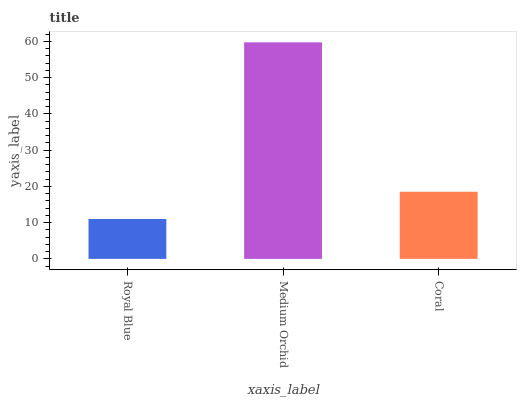Is Royal Blue the minimum?
Answer yes or no. Yes. Is Medium Orchid the maximum?
Answer yes or no. Yes. Is Coral the minimum?
Answer yes or no. No. Is Coral the maximum?
Answer yes or no. No. Is Medium Orchid greater than Coral?
Answer yes or no. Yes. Is Coral less than Medium Orchid?
Answer yes or no. Yes. Is Coral greater than Medium Orchid?
Answer yes or no. No. Is Medium Orchid less than Coral?
Answer yes or no. No. Is Coral the high median?
Answer yes or no. Yes. Is Coral the low median?
Answer yes or no. Yes. Is Royal Blue the high median?
Answer yes or no. No. Is Medium Orchid the low median?
Answer yes or no. No. 